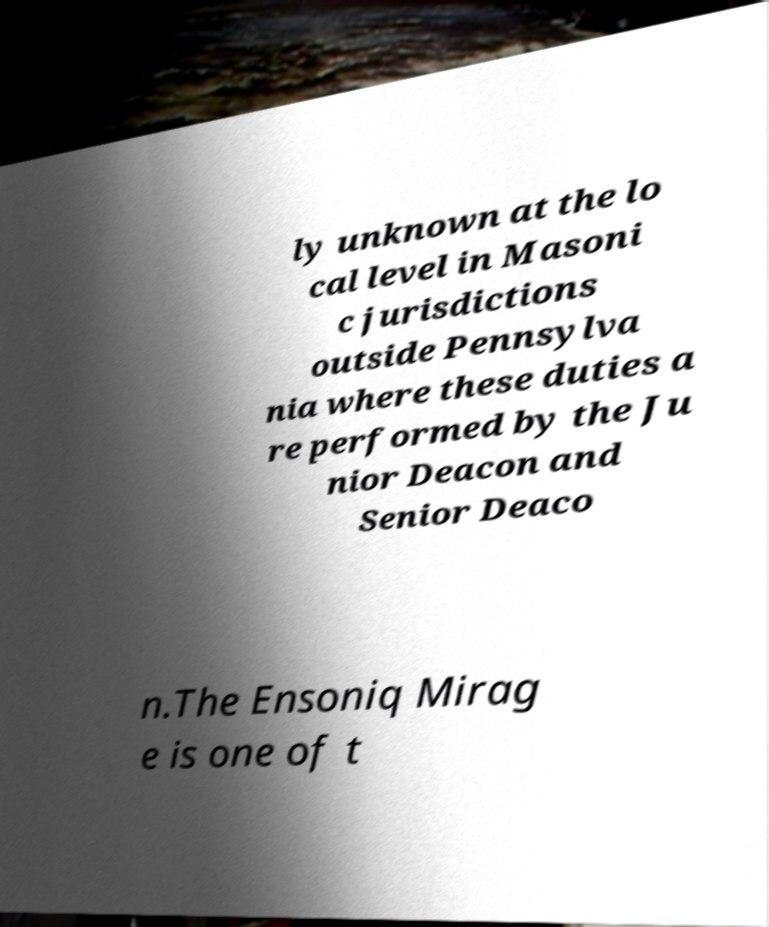Could you assist in decoding the text presented in this image and type it out clearly? ly unknown at the lo cal level in Masoni c jurisdictions outside Pennsylva nia where these duties a re performed by the Ju nior Deacon and Senior Deaco n.The Ensoniq Mirag e is one of t 